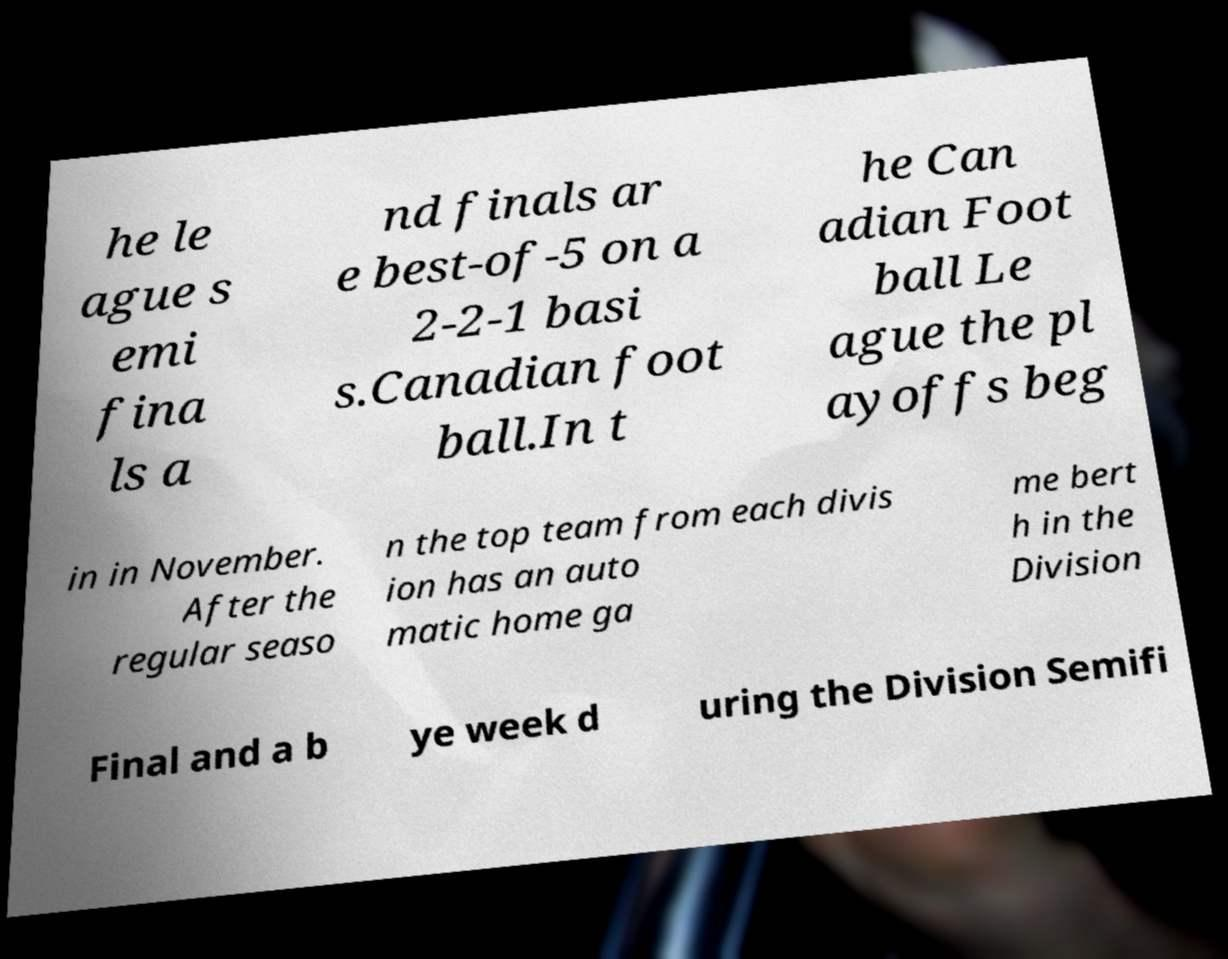What messages or text are displayed in this image? I need them in a readable, typed format. he le ague s emi fina ls a nd finals ar e best-of-5 on a 2-2-1 basi s.Canadian foot ball.In t he Can adian Foot ball Le ague the pl ayoffs beg in in November. After the regular seaso n the top team from each divis ion has an auto matic home ga me bert h in the Division Final and a b ye week d uring the Division Semifi 